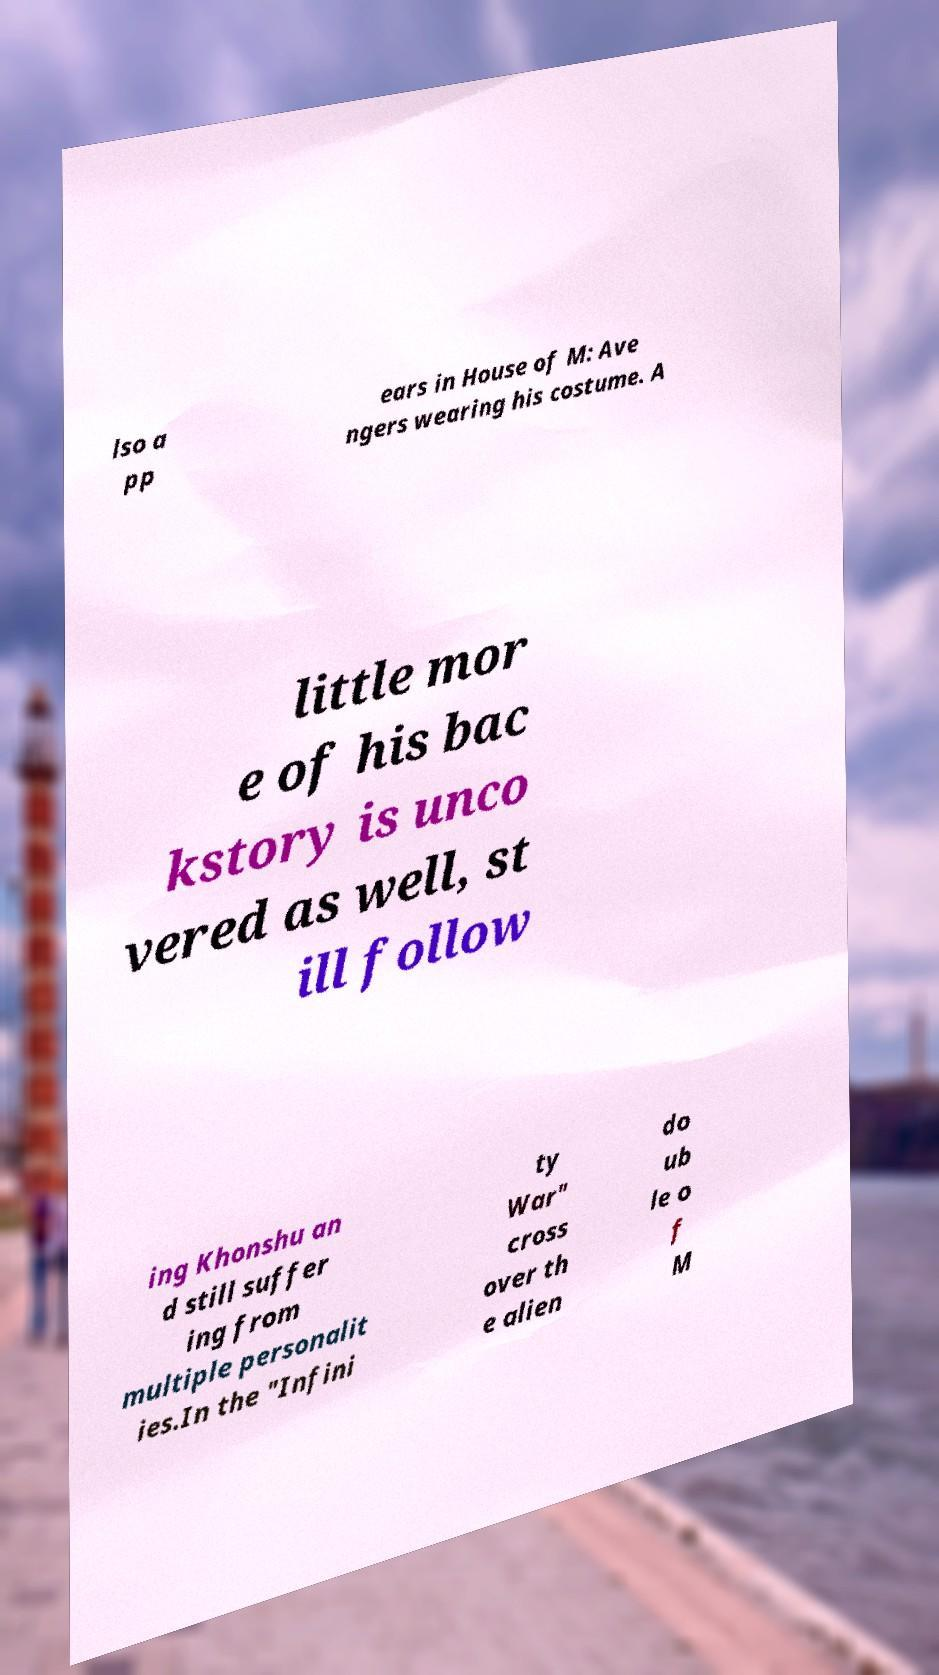What messages or text are displayed in this image? I need them in a readable, typed format. lso a pp ears in House of M: Ave ngers wearing his costume. A little mor e of his bac kstory is unco vered as well, st ill follow ing Khonshu an d still suffer ing from multiple personalit ies.In the "Infini ty War" cross over th e alien do ub le o f M 